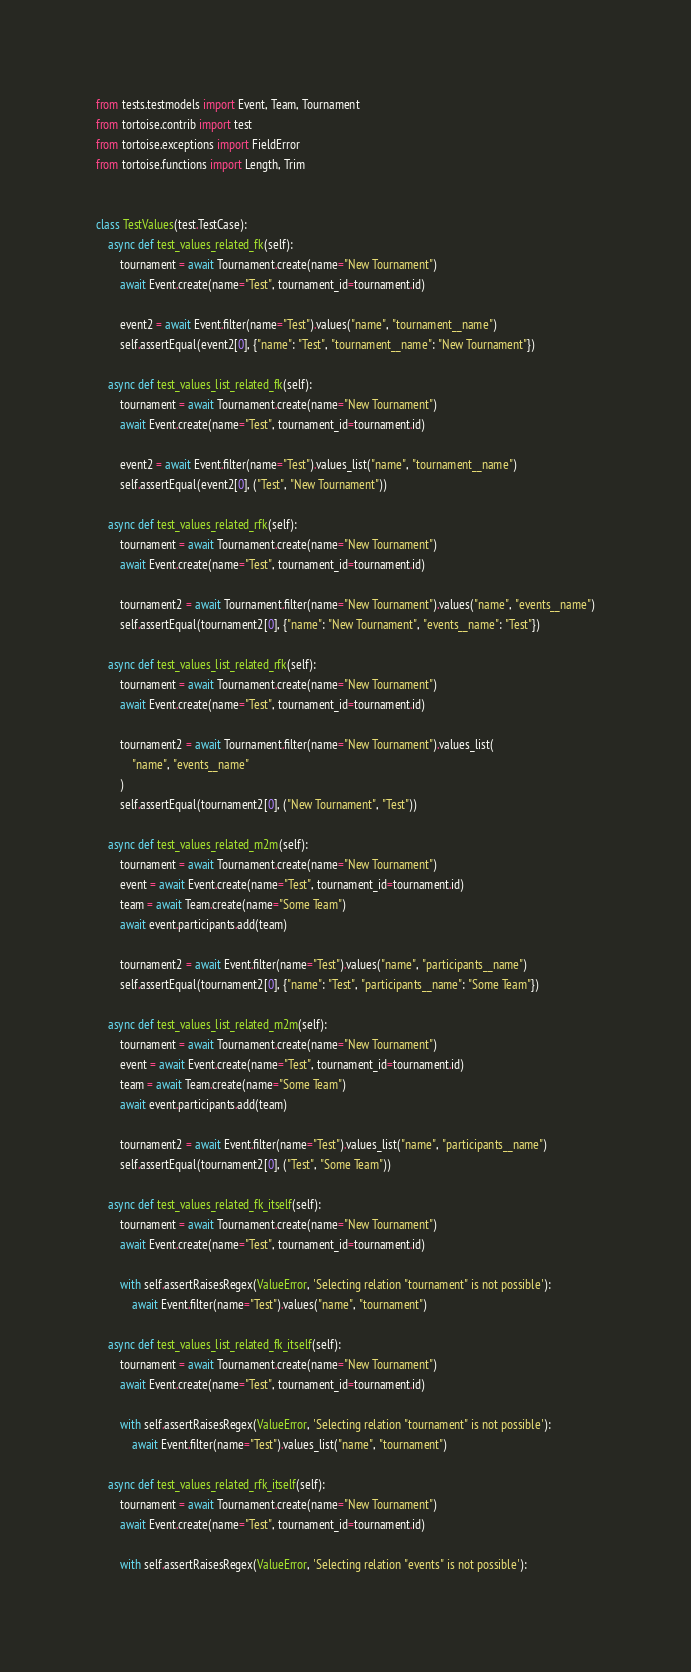<code> <loc_0><loc_0><loc_500><loc_500><_Python_>from tests.testmodels import Event, Team, Tournament
from tortoise.contrib import test
from tortoise.exceptions import FieldError
from tortoise.functions import Length, Trim


class TestValues(test.TestCase):
    async def test_values_related_fk(self):
        tournament = await Tournament.create(name="New Tournament")
        await Event.create(name="Test", tournament_id=tournament.id)

        event2 = await Event.filter(name="Test").values("name", "tournament__name")
        self.assertEqual(event2[0], {"name": "Test", "tournament__name": "New Tournament"})

    async def test_values_list_related_fk(self):
        tournament = await Tournament.create(name="New Tournament")
        await Event.create(name="Test", tournament_id=tournament.id)

        event2 = await Event.filter(name="Test").values_list("name", "tournament__name")
        self.assertEqual(event2[0], ("Test", "New Tournament"))

    async def test_values_related_rfk(self):
        tournament = await Tournament.create(name="New Tournament")
        await Event.create(name="Test", tournament_id=tournament.id)

        tournament2 = await Tournament.filter(name="New Tournament").values("name", "events__name")
        self.assertEqual(tournament2[0], {"name": "New Tournament", "events__name": "Test"})

    async def test_values_list_related_rfk(self):
        tournament = await Tournament.create(name="New Tournament")
        await Event.create(name="Test", tournament_id=tournament.id)

        tournament2 = await Tournament.filter(name="New Tournament").values_list(
            "name", "events__name"
        )
        self.assertEqual(tournament2[0], ("New Tournament", "Test"))

    async def test_values_related_m2m(self):
        tournament = await Tournament.create(name="New Tournament")
        event = await Event.create(name="Test", tournament_id=tournament.id)
        team = await Team.create(name="Some Team")
        await event.participants.add(team)

        tournament2 = await Event.filter(name="Test").values("name", "participants__name")
        self.assertEqual(tournament2[0], {"name": "Test", "participants__name": "Some Team"})

    async def test_values_list_related_m2m(self):
        tournament = await Tournament.create(name="New Tournament")
        event = await Event.create(name="Test", tournament_id=tournament.id)
        team = await Team.create(name="Some Team")
        await event.participants.add(team)

        tournament2 = await Event.filter(name="Test").values_list("name", "participants__name")
        self.assertEqual(tournament2[0], ("Test", "Some Team"))

    async def test_values_related_fk_itself(self):
        tournament = await Tournament.create(name="New Tournament")
        await Event.create(name="Test", tournament_id=tournament.id)

        with self.assertRaisesRegex(ValueError, 'Selecting relation "tournament" is not possible'):
            await Event.filter(name="Test").values("name", "tournament")

    async def test_values_list_related_fk_itself(self):
        tournament = await Tournament.create(name="New Tournament")
        await Event.create(name="Test", tournament_id=tournament.id)

        with self.assertRaisesRegex(ValueError, 'Selecting relation "tournament" is not possible'):
            await Event.filter(name="Test").values_list("name", "tournament")

    async def test_values_related_rfk_itself(self):
        tournament = await Tournament.create(name="New Tournament")
        await Event.create(name="Test", tournament_id=tournament.id)

        with self.assertRaisesRegex(ValueError, 'Selecting relation "events" is not possible'):</code> 